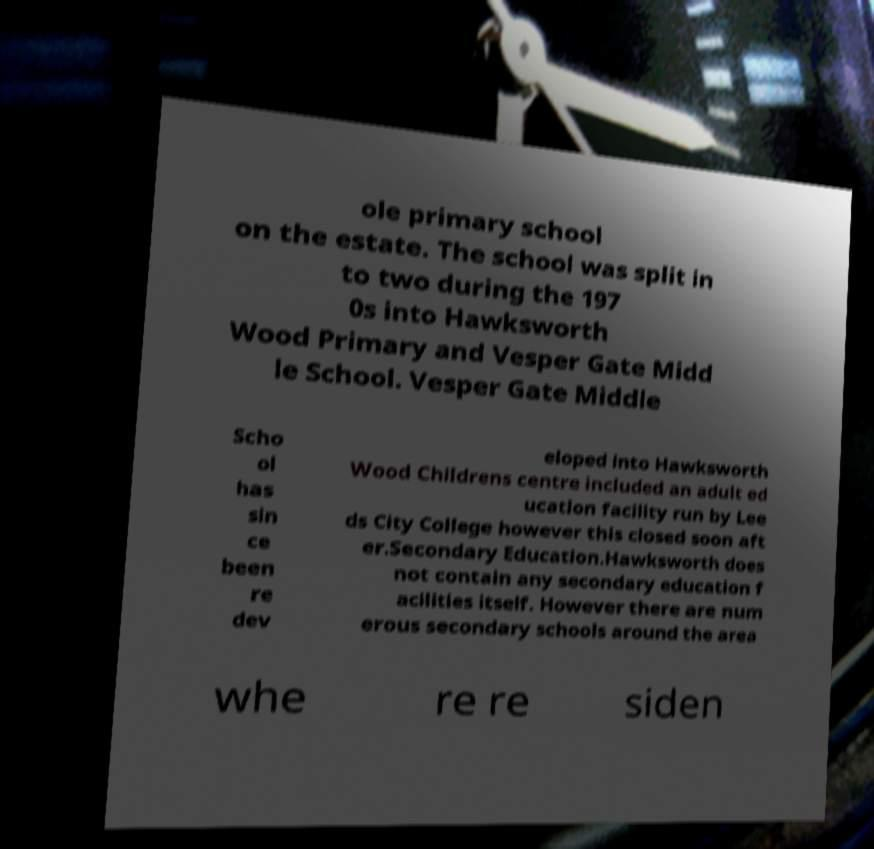Can you accurately transcribe the text from the provided image for me? ole primary school on the estate. The school was split in to two during the 197 0s into Hawksworth Wood Primary and Vesper Gate Midd le School. Vesper Gate Middle Scho ol has sin ce been re dev eloped into Hawksworth Wood Childrens centre included an adult ed ucation facility run by Lee ds City College however this closed soon aft er.Secondary Education.Hawksworth does not contain any secondary education f acilities itself. However there are num erous secondary schools around the area whe re re siden 